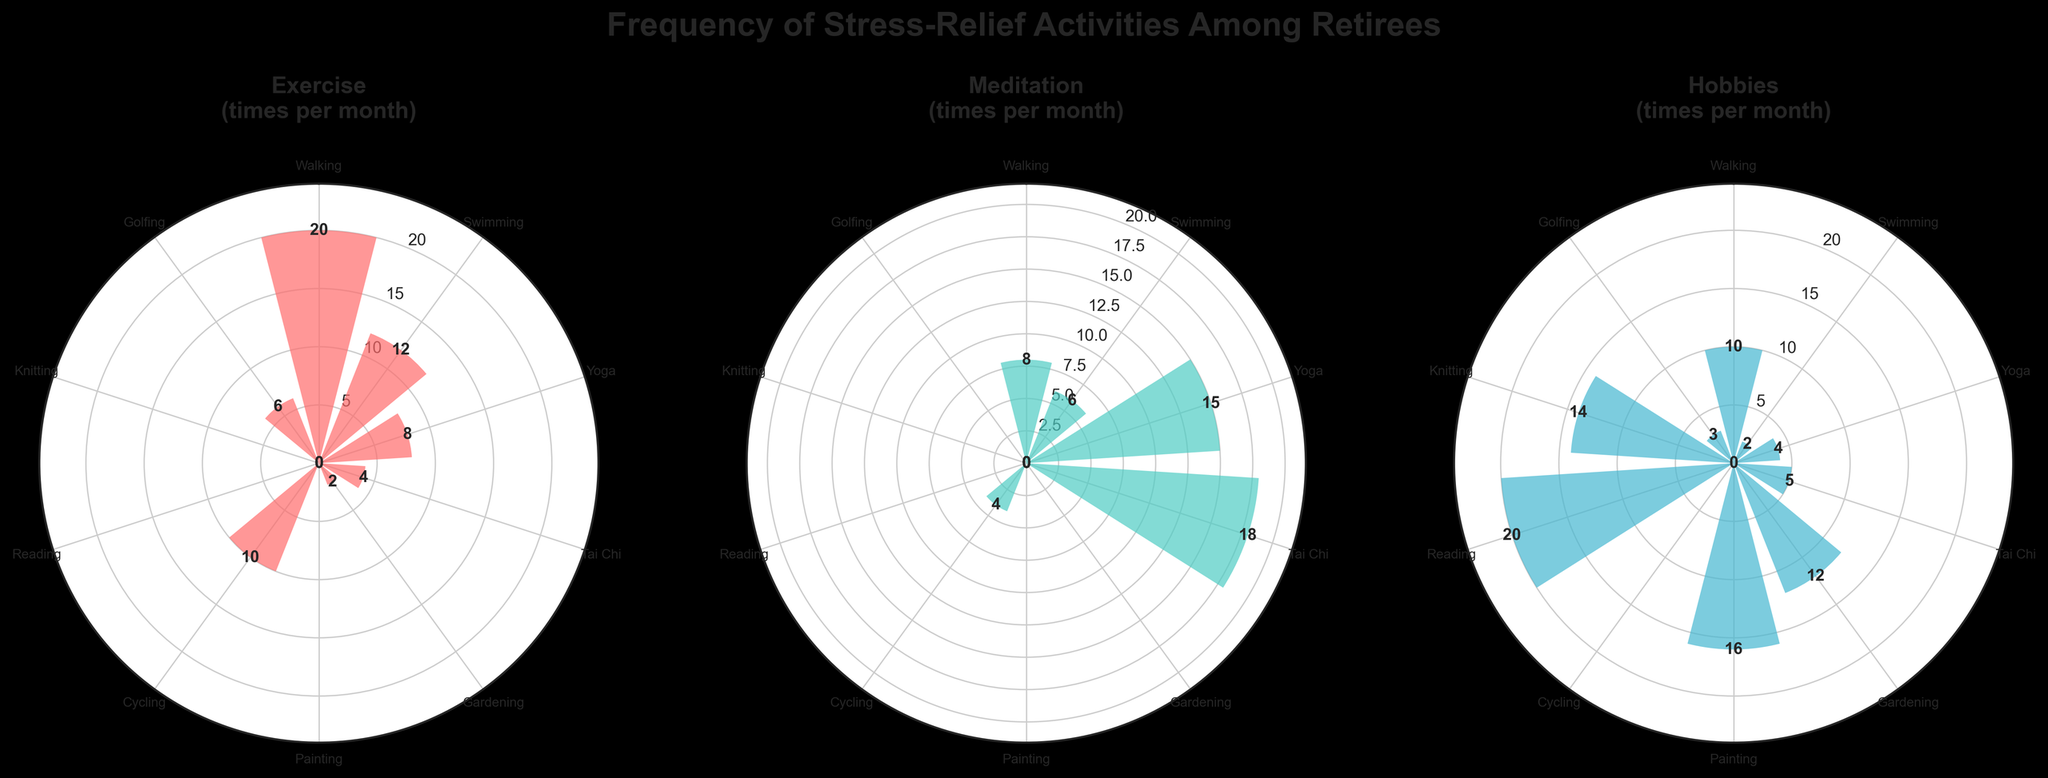What is the title of the plot? The title is displayed at the top of the entire figure in a larger font size. It reads “Frequency of Stress-Relief Activities Among Retirees.”
Answer: Frequency of Stress-Relief Activities Among Retirees How many activities are shown on each rose chart? Each chart has bars for the number of activities, represented by different angles. The angles correspond to the 10 activities listed in the data.
Answer: 10 Which activity has the highest frequency for exercise? Looking at the “Exercise” rose chart, the bar with the greatest height corresponds to "Walking," which has a frequency of 20 times per month.
Answer: Walking Which two activities have the highest frequency for meditation? Observing the “Meditation” rose chart, "Tai Chi" shows a frequency of 18 times, and "Yoga" has a frequency of 15 times per month.
Answer: Tai Chi and Yoga Which activity is most frequent in the hobbies category? Looking at the “Hobbies” rose chart, the highest peak is labeled "Reading" with a frequency of 20 times per month.
Answer: Reading Is the frequency of meditation for "Swimming" higher or lower than "Yoga"? Comparing the bar heights in the “Meditation” rose chart, "Swimming" has a frequency of 6, and "Yoga" has a frequency of 15. So, "Swimming" is lower.
Answer: Lower What is the total frequency of "Gardening" across all three categories? Observing the three rose charts, "Gardening" shows frequencies of 2 for exercise, 0 for meditation, and 12 for hobbies. Adding these, 2 + 0 + 12 = 14.
Answer: 14 Which category shows the lowest frequency for "Painting"? Checking all three charts, "Painting" has a frequency of 0 for both exercise and meditation, but 16 for hobbies. The lowest frequency is in both exercise and meditation.
Answer: Exercise and Meditation Which activity is done least frequently overall across all three categories? Summing up the frequencies in all charts. "Cycling" shows 10 (exercise) + 4 (meditation) = 14 overall, yet activities like "Gardening" have a lower total frequency (2 exercise + 12 hobbies = 14); "Knitting" and "Golfing" both have higher totals. So, any with a combined lower would lead to "Cycling" having 14 overall.
Answer: Knitting How does the frequency of "Golfing" in exercise compare with meditation? The rose chart for “Exercise” shows "Golfing" at 6 and for "Meditation," it's 0. Thus, exercise frequency is higher for "Golfing."
Answer: Higher 